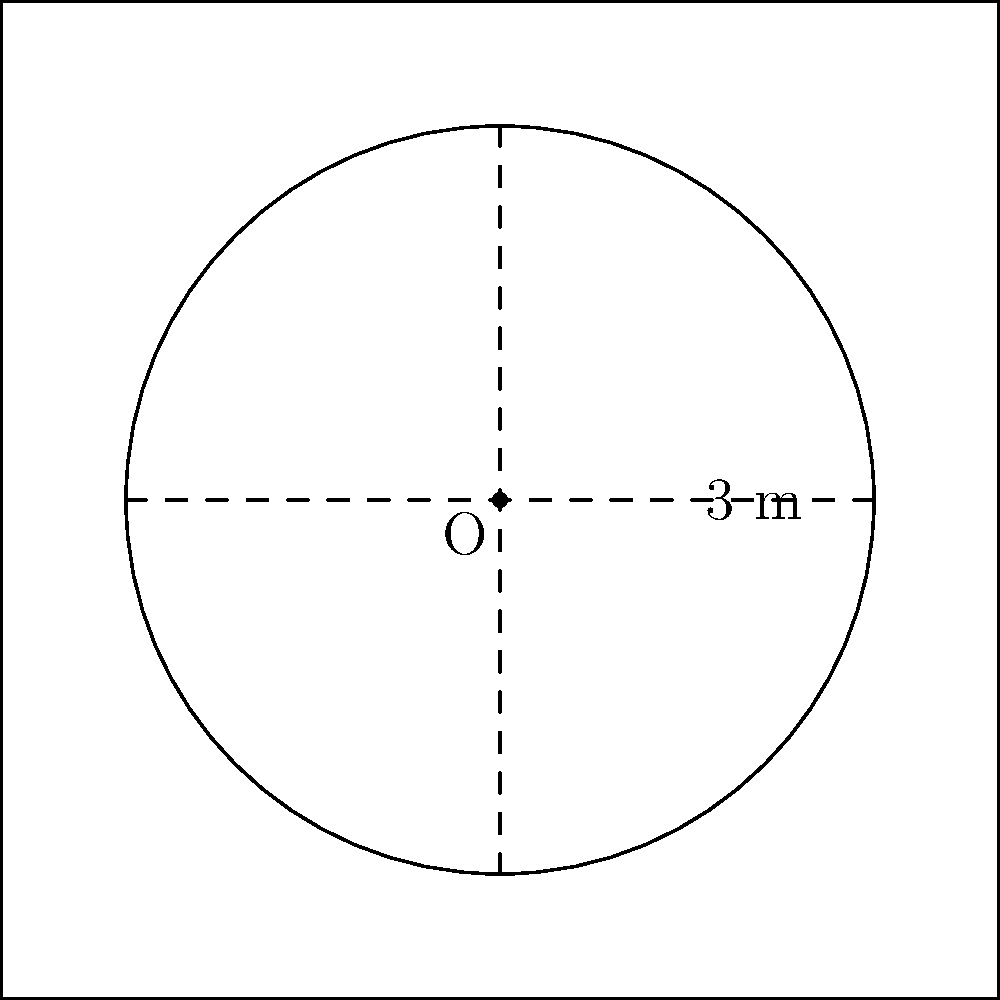In lacrosse, the goal crease is a circular area around the goal. If the radius of the goal crease is 3 meters and its center is at the origin (0,0), what is the area of the goal crease in square meters? Use the equation of a circle to determine your answer. To solve this problem, we'll follow these steps:

1) The general equation of a circle is $$(x-h)^2 + (y-k)^2 = r^2$$
   where (h,k) is the center and r is the radius.

2) In this case, the center is at (0,0) and the radius is 3 meters.
   So our equation becomes: $$x^2 + y^2 = 3^2 = 9$$

3) To find the area, we use the formula: $$A = \pi r^2$$

4) We know r = 3, so:
   $$A = \pi (3)^2 = 9\pi$$

5) Therefore, the area of the goal crease is $9\pi$ square meters.

This knowledge of circular areas can help a lacrosse player understand the space they have to work with around the goal, potentially improving their positioning and movement strategies.
Answer: $9\pi$ square meters 